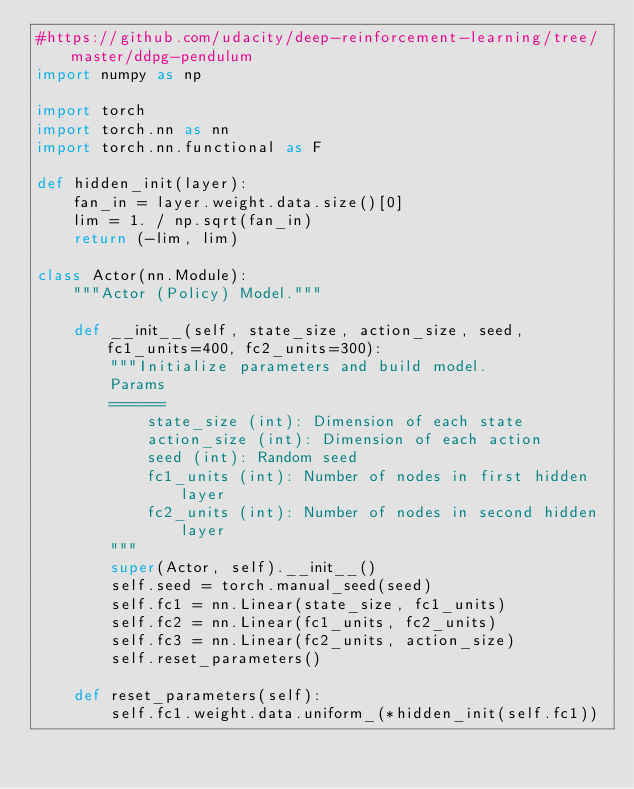<code> <loc_0><loc_0><loc_500><loc_500><_Python_>#https://github.com/udacity/deep-reinforcement-learning/tree/master/ddpg-pendulum
import numpy as np

import torch
import torch.nn as nn
import torch.nn.functional as F

def hidden_init(layer):
    fan_in = layer.weight.data.size()[0]
    lim = 1. / np.sqrt(fan_in)
    return (-lim, lim)

class Actor(nn.Module):
    """Actor (Policy) Model."""

    def __init__(self, state_size, action_size, seed, fc1_units=400, fc2_units=300):
        """Initialize parameters and build model.
        Params
        ======
            state_size (int): Dimension of each state
            action_size (int): Dimension of each action
            seed (int): Random seed
            fc1_units (int): Number of nodes in first hidden layer
            fc2_units (int): Number of nodes in second hidden layer
        """
        super(Actor, self).__init__()
        self.seed = torch.manual_seed(seed)
        self.fc1 = nn.Linear(state_size, fc1_units)
        self.fc2 = nn.Linear(fc1_units, fc2_units)
        self.fc3 = nn.Linear(fc2_units, action_size)
        self.reset_parameters()

    def reset_parameters(self):
        self.fc1.weight.data.uniform_(*hidden_init(self.fc1))</code> 